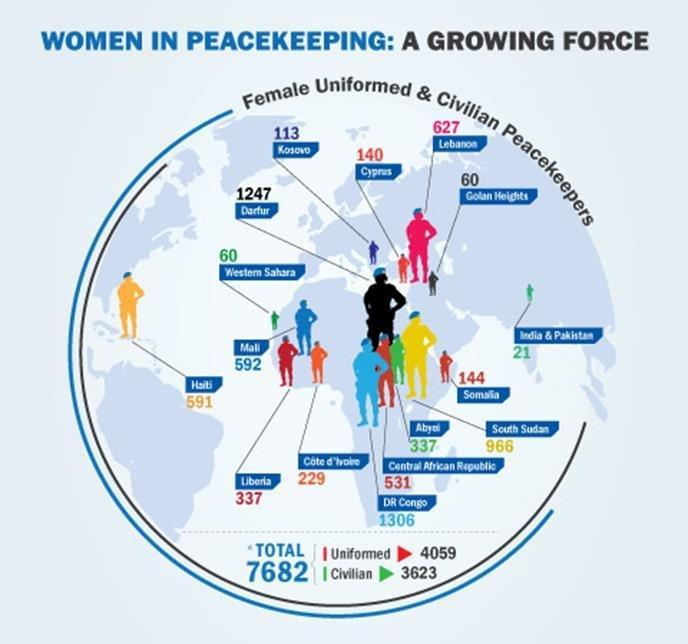What is the number of female uniformed & civilian peacekeepers in Mali and Cyprus, taken together?
Answer the question with a short phrase. 732 